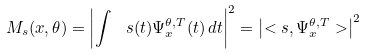<formula> <loc_0><loc_0><loc_500><loc_500>M _ { s } ( x , \theta ) = \left | \int \ s ( t ) \Psi _ { x } ^ { \theta , T } ( t ) \, d t \right | ^ { 2 } = \left | < s , \Psi _ { x } ^ { \theta , T } > \right | ^ { 2 }</formula> 